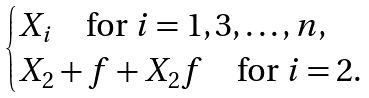<formula> <loc_0><loc_0><loc_500><loc_500>\begin{cases} X _ { i } \quad \text {for} \ i = 1 , 3 , \dots , n , \\ X _ { 2 } + f + X _ { 2 } f \quad \text {for} \ i = 2 . \end{cases}</formula> 